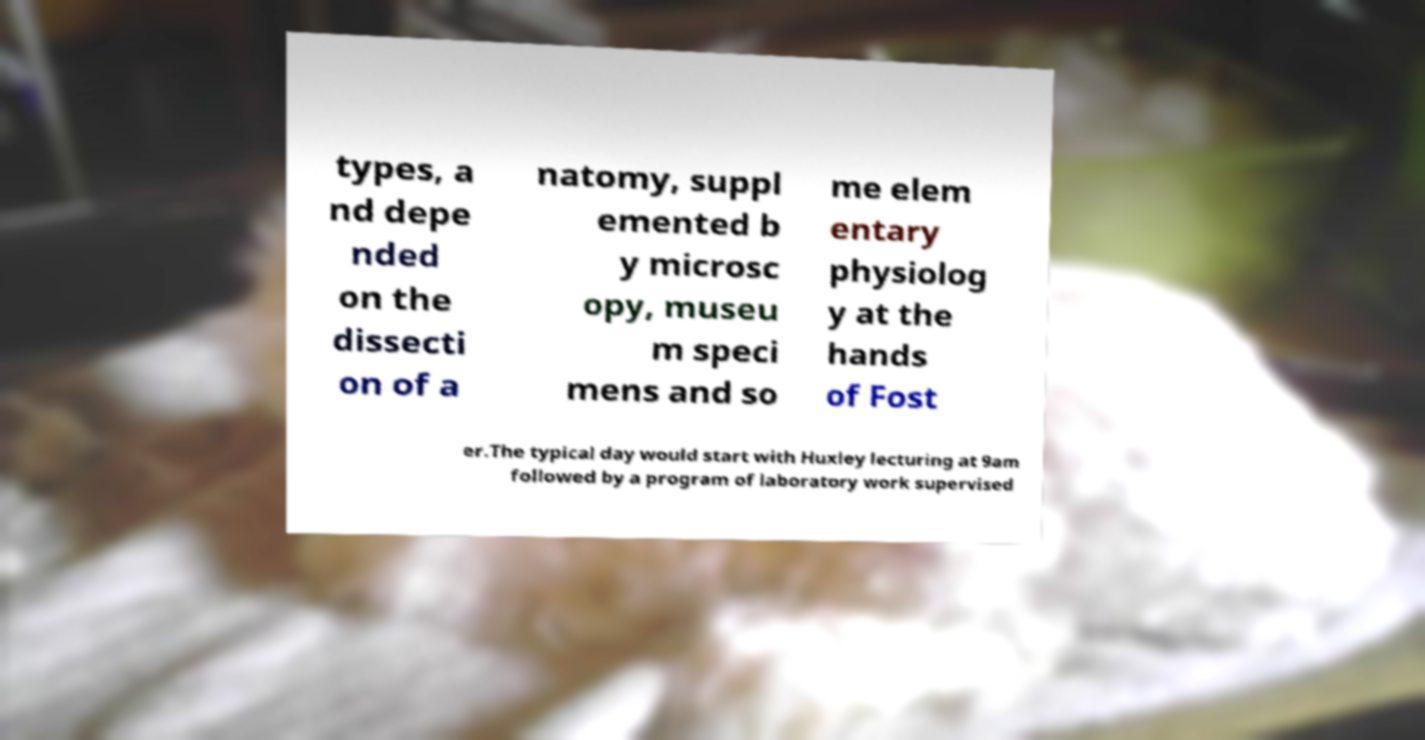Could you assist in decoding the text presented in this image and type it out clearly? types, a nd depe nded on the dissecti on of a natomy, suppl emented b y microsc opy, museu m speci mens and so me elem entary physiolog y at the hands of Fost er.The typical day would start with Huxley lecturing at 9am followed by a program of laboratory work supervised 